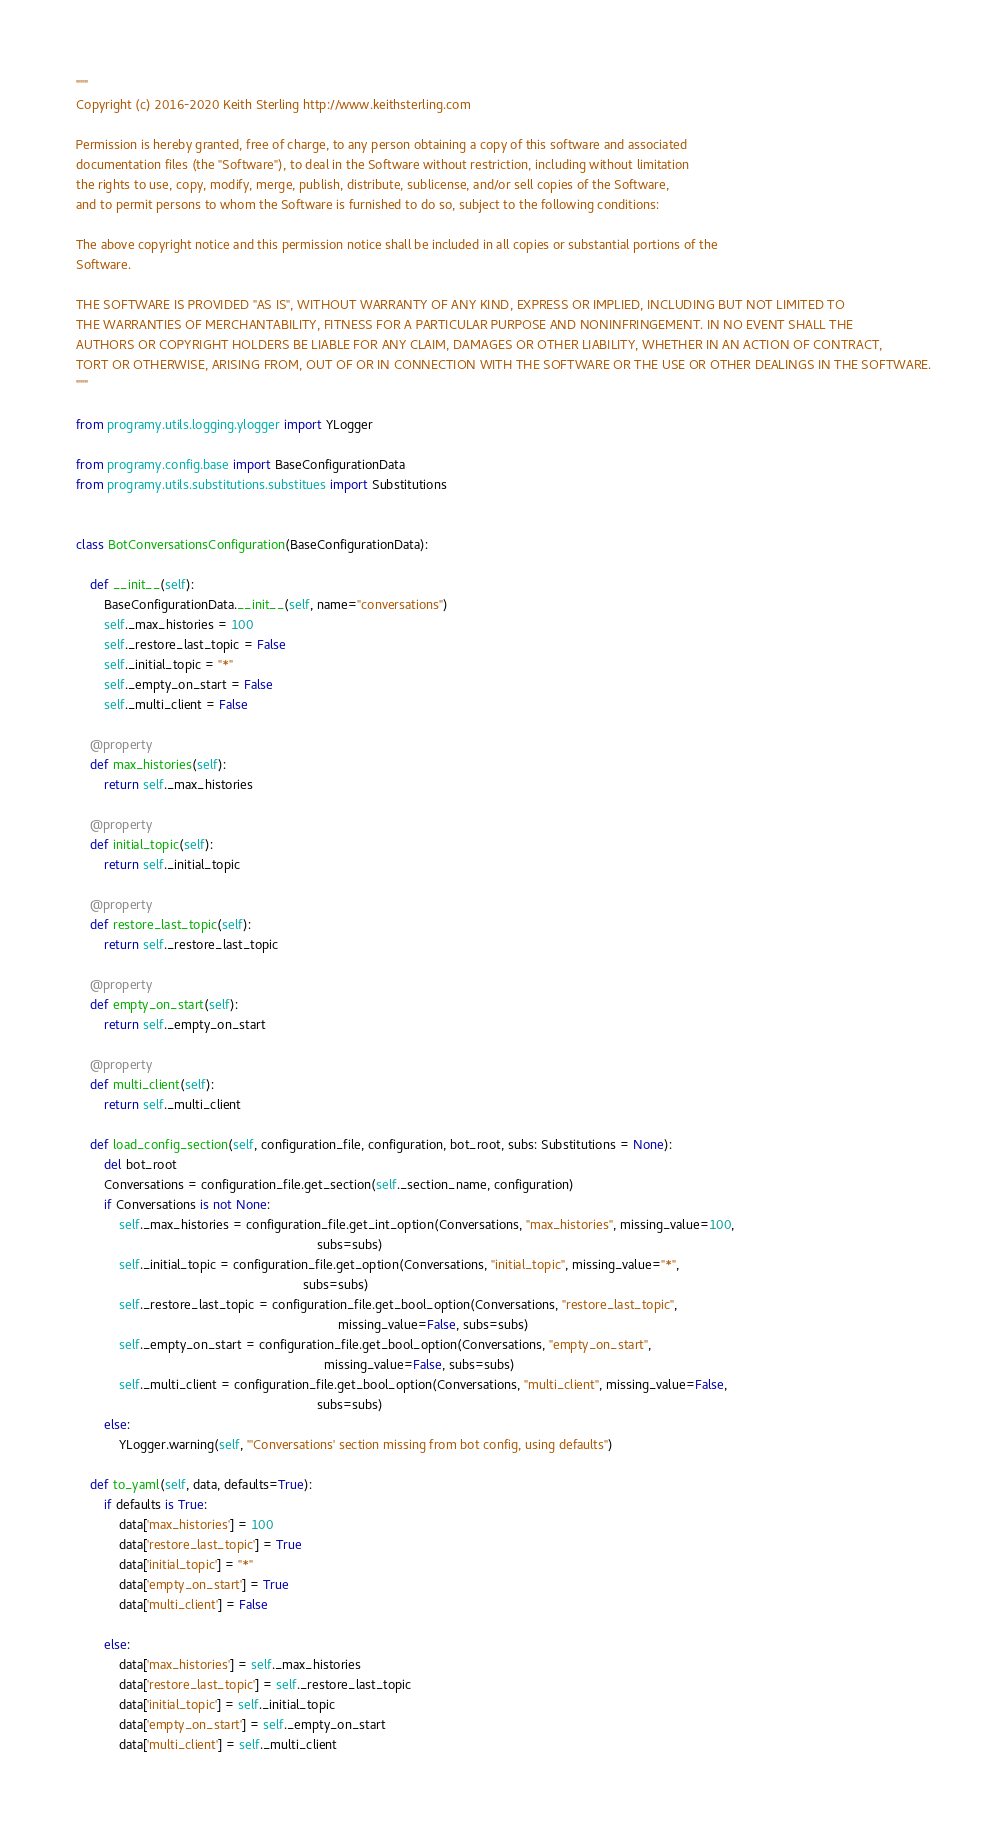Convert code to text. <code><loc_0><loc_0><loc_500><loc_500><_Python_>"""
Copyright (c) 2016-2020 Keith Sterling http://www.keithsterling.com

Permission is hereby granted, free of charge, to any person obtaining a copy of this software and associated
documentation files (the "Software"), to deal in the Software without restriction, including without limitation
the rights to use, copy, modify, merge, publish, distribute, sublicense, and/or sell copies of the Software,
and to permit persons to whom the Software is furnished to do so, subject to the following conditions:

The above copyright notice and this permission notice shall be included in all copies or substantial portions of the
Software.

THE SOFTWARE IS PROVIDED "AS IS", WITHOUT WARRANTY OF ANY KIND, EXPRESS OR IMPLIED, INCLUDING BUT NOT LIMITED TO
THE WARRANTIES OF MERCHANTABILITY, FITNESS FOR A PARTICULAR PURPOSE AND NONINFRINGEMENT. IN NO EVENT SHALL THE
AUTHORS OR COPYRIGHT HOLDERS BE LIABLE FOR ANY CLAIM, DAMAGES OR OTHER LIABILITY, WHETHER IN AN ACTION OF CONTRACT,
TORT OR OTHERWISE, ARISING FROM, OUT OF OR IN CONNECTION WITH THE SOFTWARE OR THE USE OR OTHER DEALINGS IN THE SOFTWARE.
"""

from programy.utils.logging.ylogger import YLogger

from programy.config.base import BaseConfigurationData
from programy.utils.substitutions.substitues import Substitutions


class BotConversationsConfiguration(BaseConfigurationData):

    def __init__(self):
        BaseConfigurationData.__init__(self, name="conversations")
        self._max_histories = 100
        self._restore_last_topic = False
        self._initial_topic = "*"
        self._empty_on_start = False
        self._multi_client = False

    @property
    def max_histories(self):
        return self._max_histories

    @property
    def initial_topic(self):
        return self._initial_topic

    @property
    def restore_last_topic(self):
        return self._restore_last_topic

    @property
    def empty_on_start(self):
        return self._empty_on_start

    @property
    def multi_client(self):
        return self._multi_client

    def load_config_section(self, configuration_file, configuration, bot_root, subs: Substitutions = None):
        del bot_root
        Conversations = configuration_file.get_section(self._section_name, configuration)
        if Conversations is not None:
            self._max_histories = configuration_file.get_int_option(Conversations, "max_histories", missing_value=100,
                                                                    subs=subs)
            self._initial_topic = configuration_file.get_option(Conversations, "initial_topic", missing_value="*",
                                                                subs=subs)
            self._restore_last_topic = configuration_file.get_bool_option(Conversations, "restore_last_topic",
                                                                          missing_value=False, subs=subs)
            self._empty_on_start = configuration_file.get_bool_option(Conversations, "empty_on_start",
                                                                      missing_value=False, subs=subs)
            self._multi_client = configuration_file.get_bool_option(Conversations, "multi_client", missing_value=False,
                                                                    subs=subs)
        else:
            YLogger.warning(self, "'Conversations' section missing from bot config, using defaults")

    def to_yaml(self, data, defaults=True):
        if defaults is True:
            data['max_histories'] = 100
            data['restore_last_topic'] = True
            data['initial_topic'] = "*"
            data['empty_on_start'] = True
            data['multi_client'] = False

        else:
            data['max_histories'] = self._max_histories
            data['restore_last_topic'] = self._restore_last_topic
            data['initial_topic'] = self._initial_topic
            data['empty_on_start'] = self._empty_on_start
            data['multi_client'] = self._multi_client
</code> 